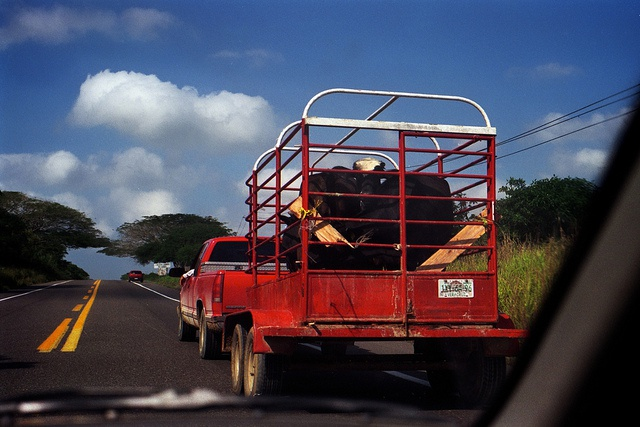Describe the objects in this image and their specific colors. I can see truck in darkblue, black, brown, maroon, and gray tones, car in darkblue, black, brown, maroon, and red tones, cow in darkblue, black, maroon, and brown tones, cow in darkblue, black, maroon, purple, and gray tones, and cow in darkblue, black, tan, beige, and gray tones in this image. 